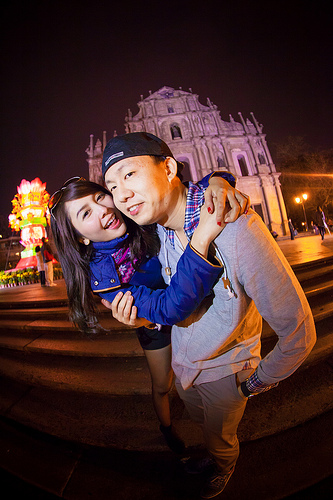<image>
Can you confirm if the girl is on the boy? Yes. Looking at the image, I can see the girl is positioned on top of the boy, with the boy providing support. 